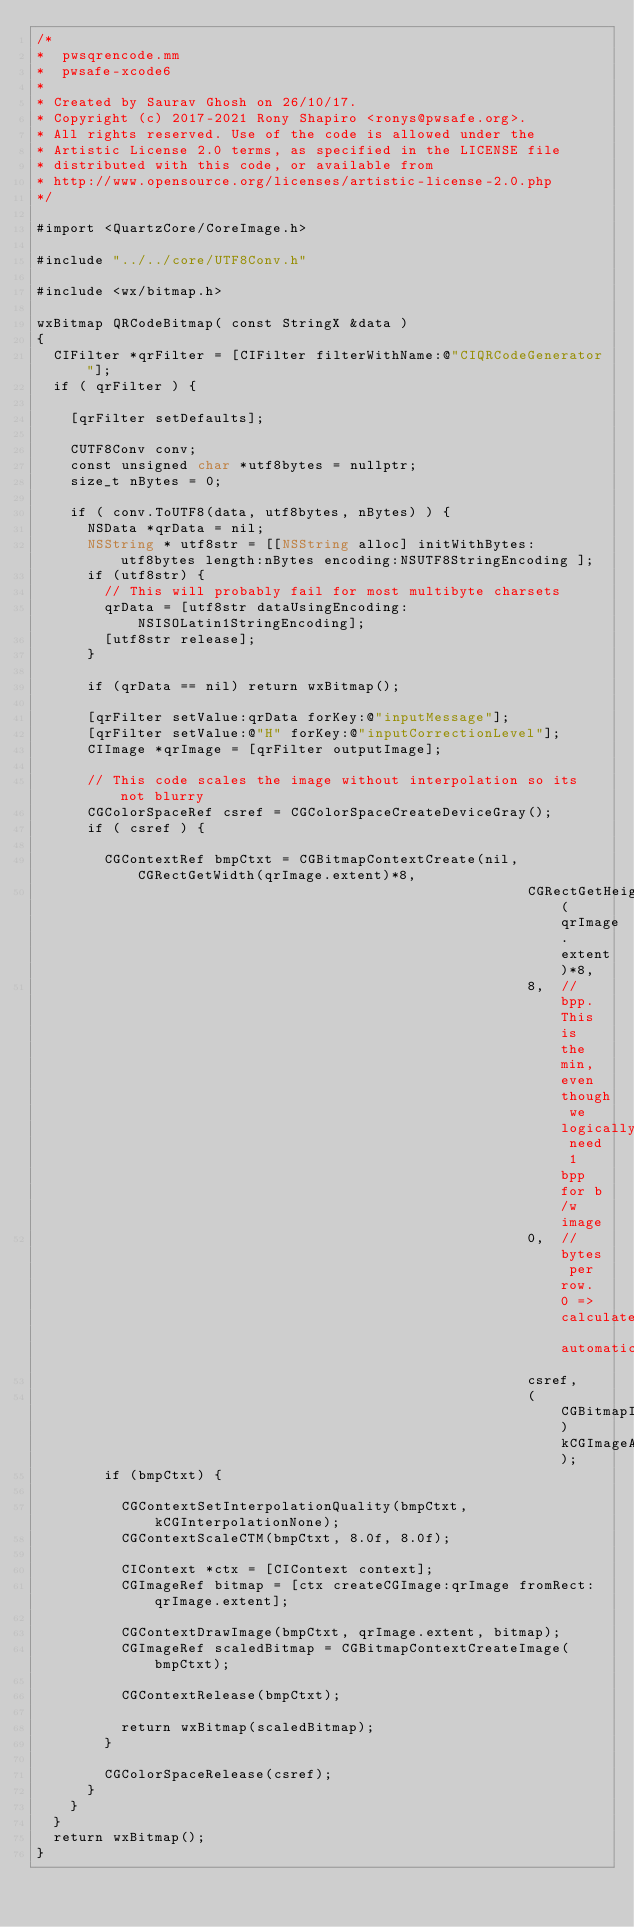Convert code to text. <code><loc_0><loc_0><loc_500><loc_500><_ObjectiveC_>/*
*  pwsqrencode.mm
*  pwsafe-xcode6
*
* Created by Saurav Ghosh on 26/10/17.
* Copyright (c) 2017-2021 Rony Shapiro <ronys@pwsafe.org>.
* All rights reserved. Use of the code is allowed under the
* Artistic License 2.0 terms, as specified in the LICENSE file
* distributed with this code, or available from
* http://www.opensource.org/licenses/artistic-license-2.0.php
*/

#import <QuartzCore/CoreImage.h>

#include "../../core/UTF8Conv.h"

#include <wx/bitmap.h>

wxBitmap QRCodeBitmap( const StringX &data )
{
	CIFilter *qrFilter = [CIFilter filterWithName:@"CIQRCodeGenerator"];
	if ( qrFilter ) {
		
    [qrFilter setDefaults];

		CUTF8Conv conv;
		const unsigned char *utf8bytes = nullptr;
		size_t nBytes = 0;
		
		if ( conv.ToUTF8(data, utf8bytes, nBytes) ) {
      NSData *qrData = nil;
			NSString * utf8str = [[NSString alloc] initWithBytes:utf8bytes length:nBytes encoding:NSUTF8StringEncoding ];
      if (utf8str) {
        // This will probably fail for most multibyte charsets
				qrData = [utf8str dataUsingEncoding:NSISOLatin1StringEncoding];
        [utf8str release];
      }

      if (qrData == nil) return wxBitmap();

      [qrFilter setValue:qrData forKey:@"inputMessage"];
      [qrFilter setValue:@"H" forKey:@"inputCorrectionLevel"];
      CIImage *qrImage = [qrFilter outputImage];

      // This code scales the image without interpolation so its not blurry
      CGColorSpaceRef csref = CGColorSpaceCreateDeviceGray();
      if ( csref ) {

        CGContextRef bmpCtxt = CGBitmapContextCreate(nil, CGRectGetWidth(qrImage.extent)*8,
                                                          CGRectGetHeight(qrImage.extent)*8,
                                                          8,  // bpp. This is the min, even though we logically need 1 bpp for b/w image
                                                          0,  // bytes per row. 0 => calculate automatically
                                                          csref,
                                                          (CGBitmapInfo)kCGImageAlphaNone);
        if (bmpCtxt) {

          CGContextSetInterpolationQuality(bmpCtxt, kCGInterpolationNone);
          CGContextScaleCTM(bmpCtxt, 8.0f, 8.0f);

          CIContext *ctx = [CIContext context];
          CGImageRef bitmap = [ctx createCGImage:qrImage fromRect:qrImage.extent];

          CGContextDrawImage(bmpCtxt, qrImage.extent, bitmap);
          CGImageRef scaledBitmap = CGBitmapContextCreateImage(bmpCtxt);

          CGContextRelease(bmpCtxt);

          return wxBitmap(scaledBitmap);
        }

        CGColorSpaceRelease(csref);
      }
		}
	}
	return wxBitmap();
}
</code> 